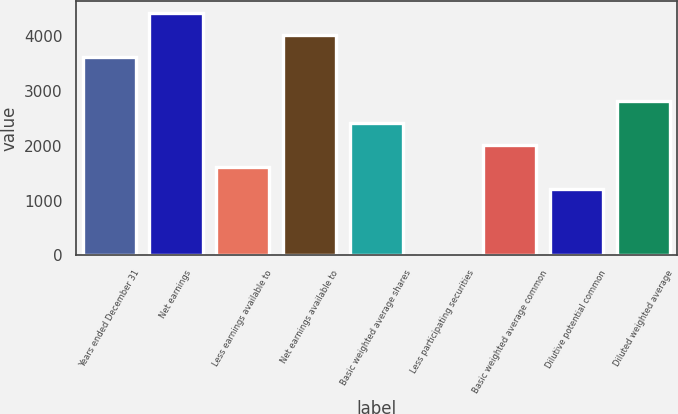Convert chart to OTSL. <chart><loc_0><loc_0><loc_500><loc_500><bar_chart><fcel>Years ended December 31<fcel>Net earnings<fcel>Less earnings available to<fcel>Net earnings available to<fcel>Basic weighted average shares<fcel>Less participating securities<fcel>Basic weighted average common<fcel>Dilutive potential common<fcel>Diluted weighted average<nl><fcel>3616.45<fcel>4419.55<fcel>1608.7<fcel>4018<fcel>2411.8<fcel>2.5<fcel>2010.25<fcel>1207.15<fcel>2813.35<nl></chart> 